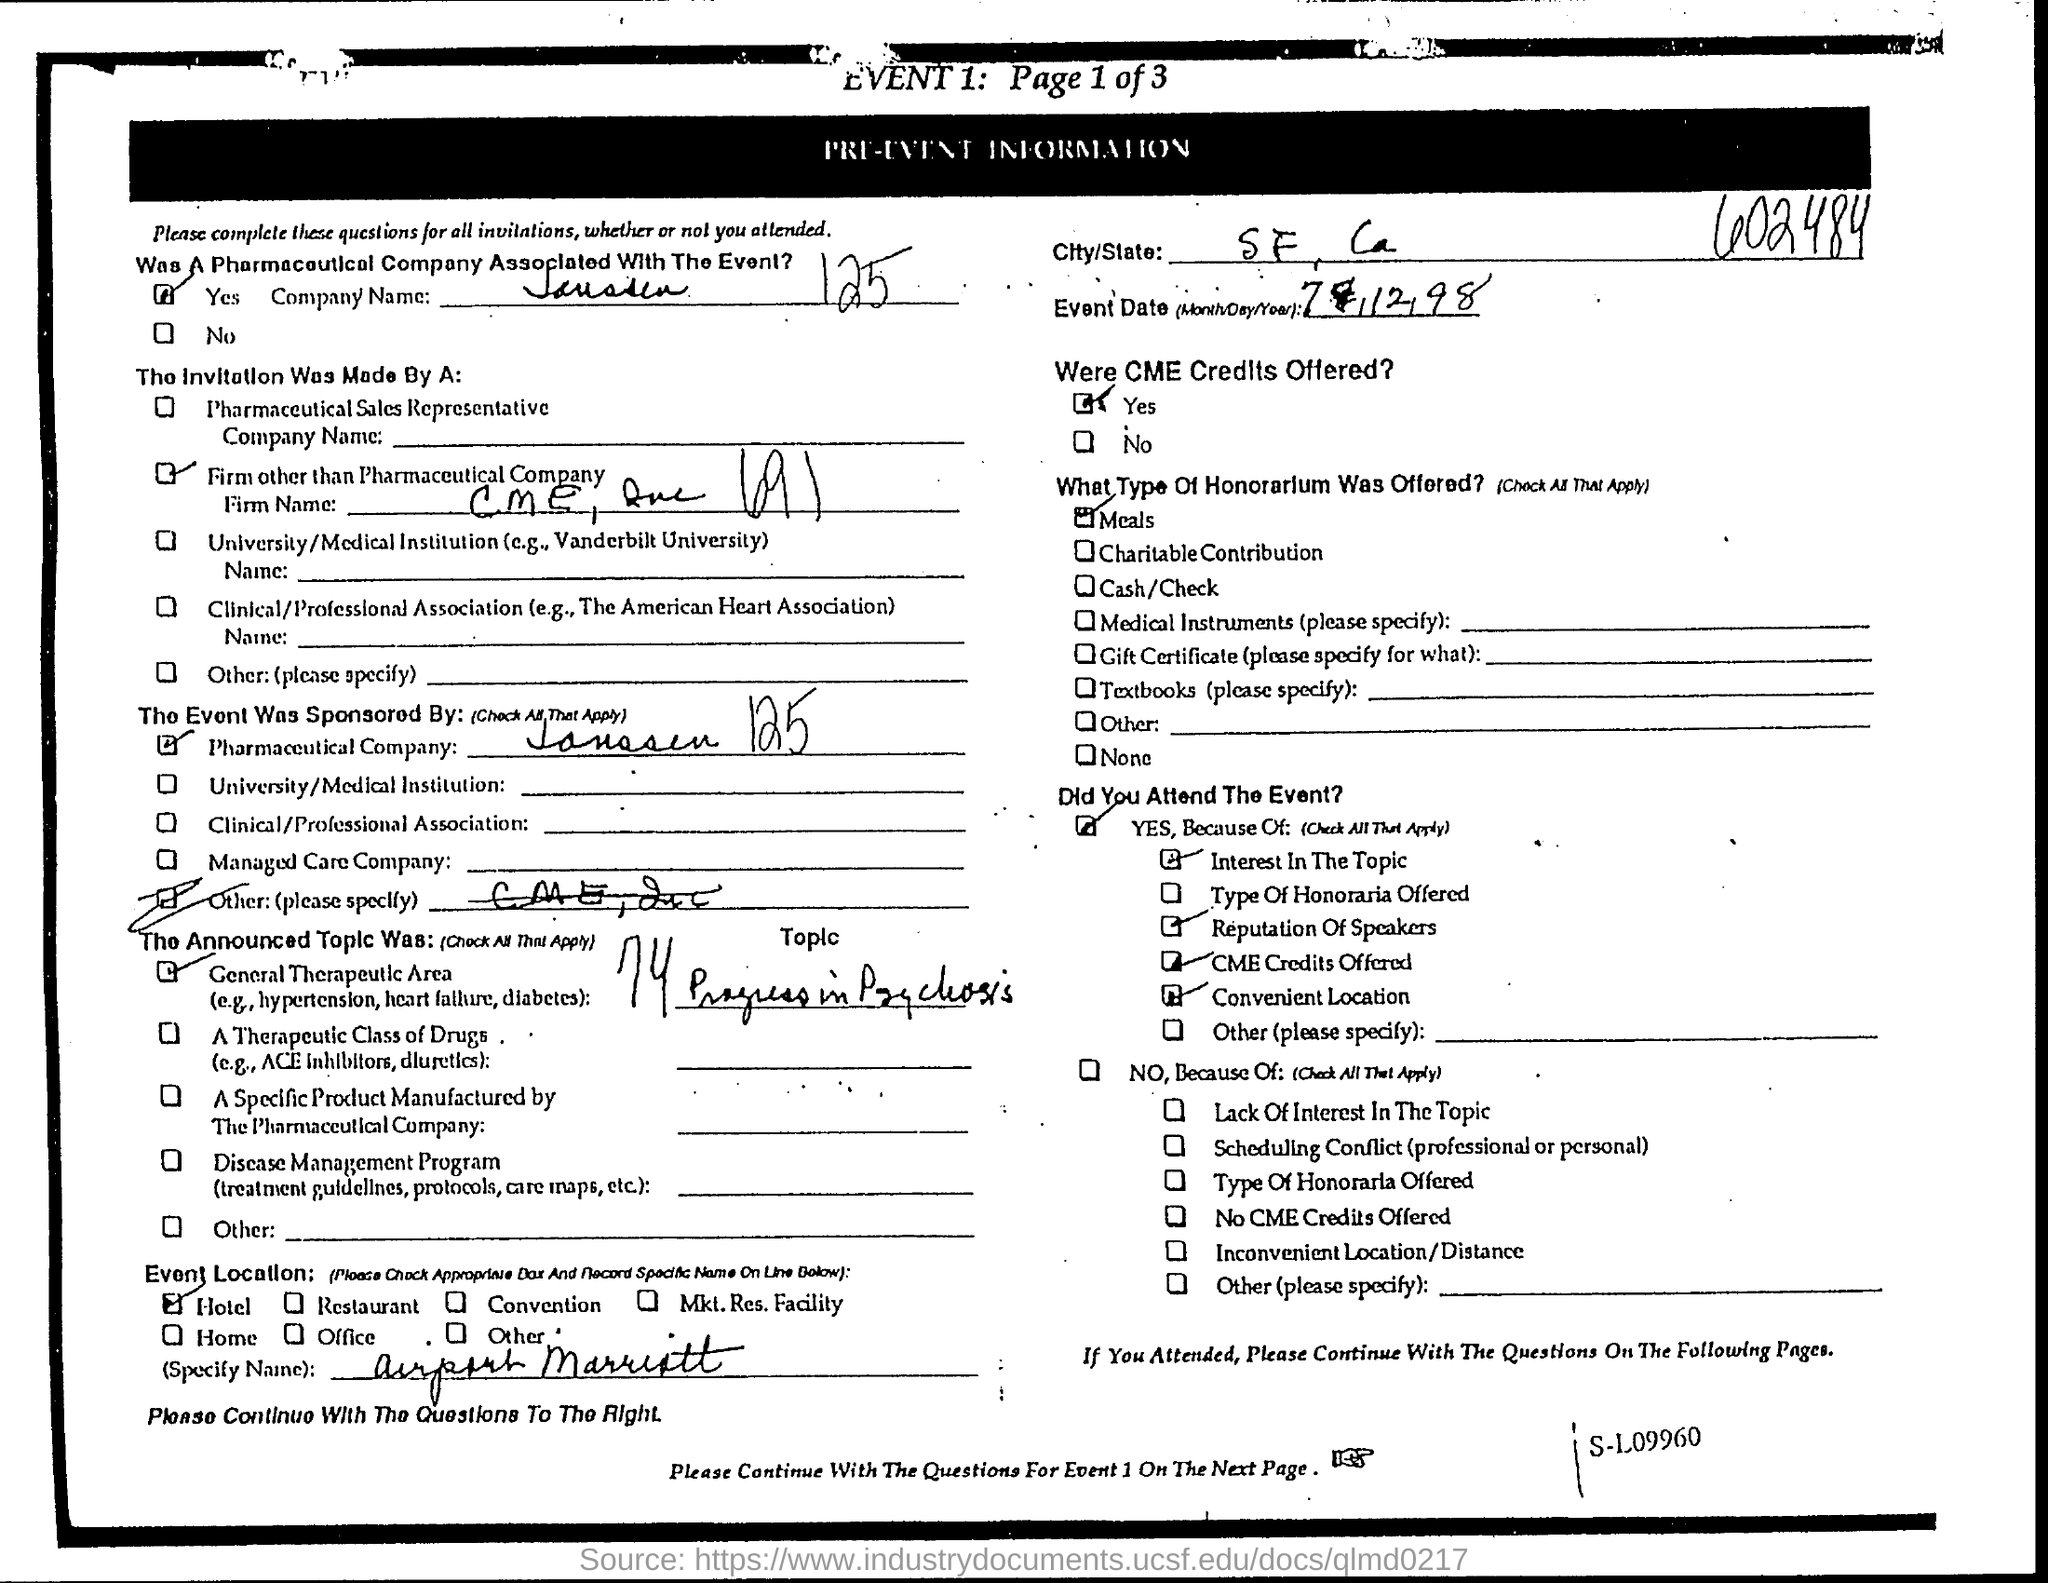Was a pharmaceutical company associated with the event?
Provide a succinct answer. Yes. What is the hotel name?
Your answer should be very brief. Airport Marriott. What is the city/state?
Give a very brief answer. SF, Ca. Were cme credits offered?
Provide a short and direct response. Yes. What type of honorarlum was offered?
Your answer should be compact. Meals. What is the event number?
Your answer should be very brief. Event 1. What is the page number mentioned?
Provide a short and direct response. Page 1 of 3. 